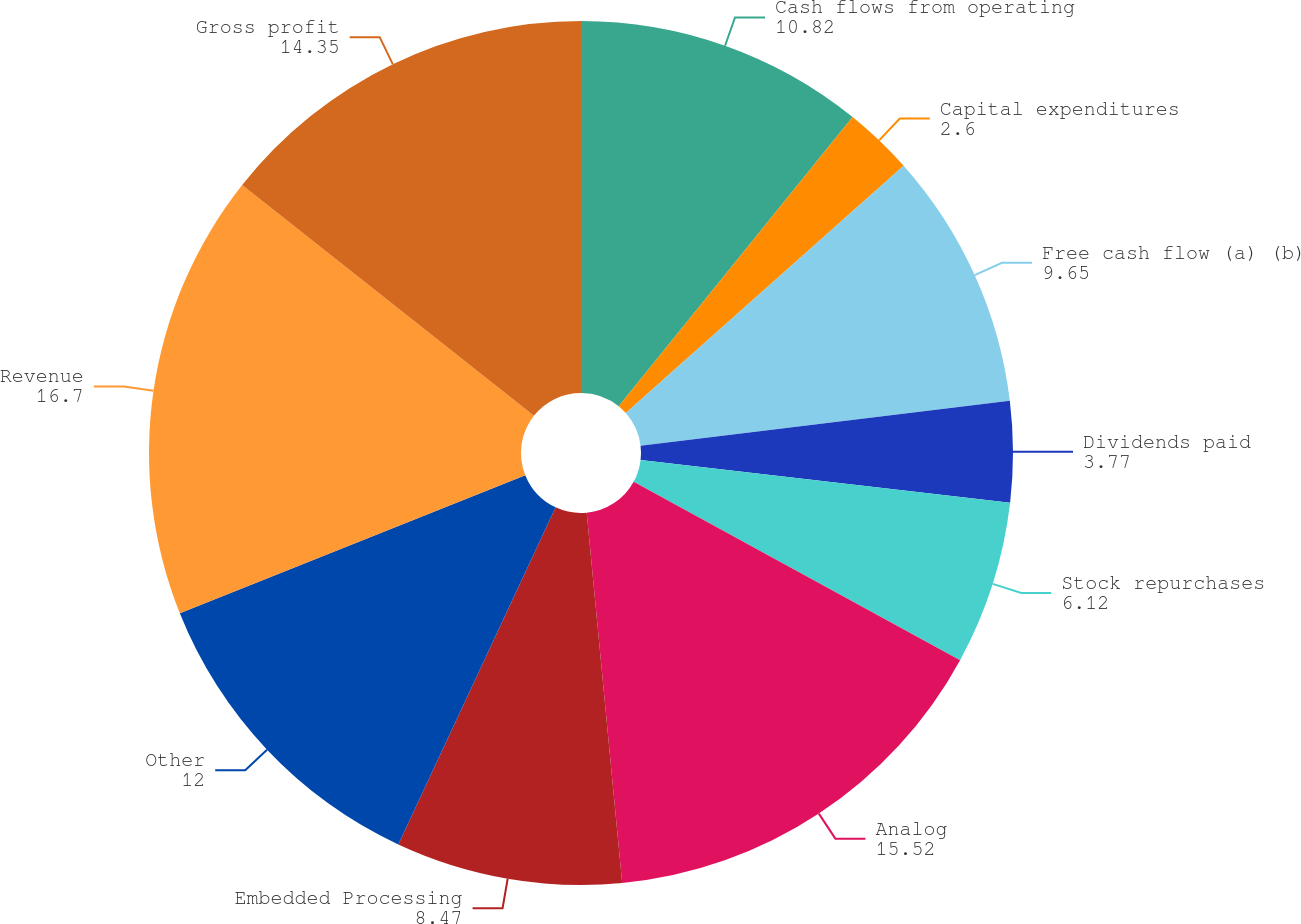Convert chart. <chart><loc_0><loc_0><loc_500><loc_500><pie_chart><fcel>Cash flows from operating<fcel>Capital expenditures<fcel>Free cash flow (a) (b)<fcel>Dividends paid<fcel>Stock repurchases<fcel>Analog<fcel>Embedded Processing<fcel>Other<fcel>Revenue<fcel>Gross profit<nl><fcel>10.82%<fcel>2.6%<fcel>9.65%<fcel>3.77%<fcel>6.12%<fcel>15.52%<fcel>8.47%<fcel>12.0%<fcel>16.7%<fcel>14.35%<nl></chart> 